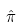Convert formula to latex. <formula><loc_0><loc_0><loc_500><loc_500>\hat { \pi }</formula> 